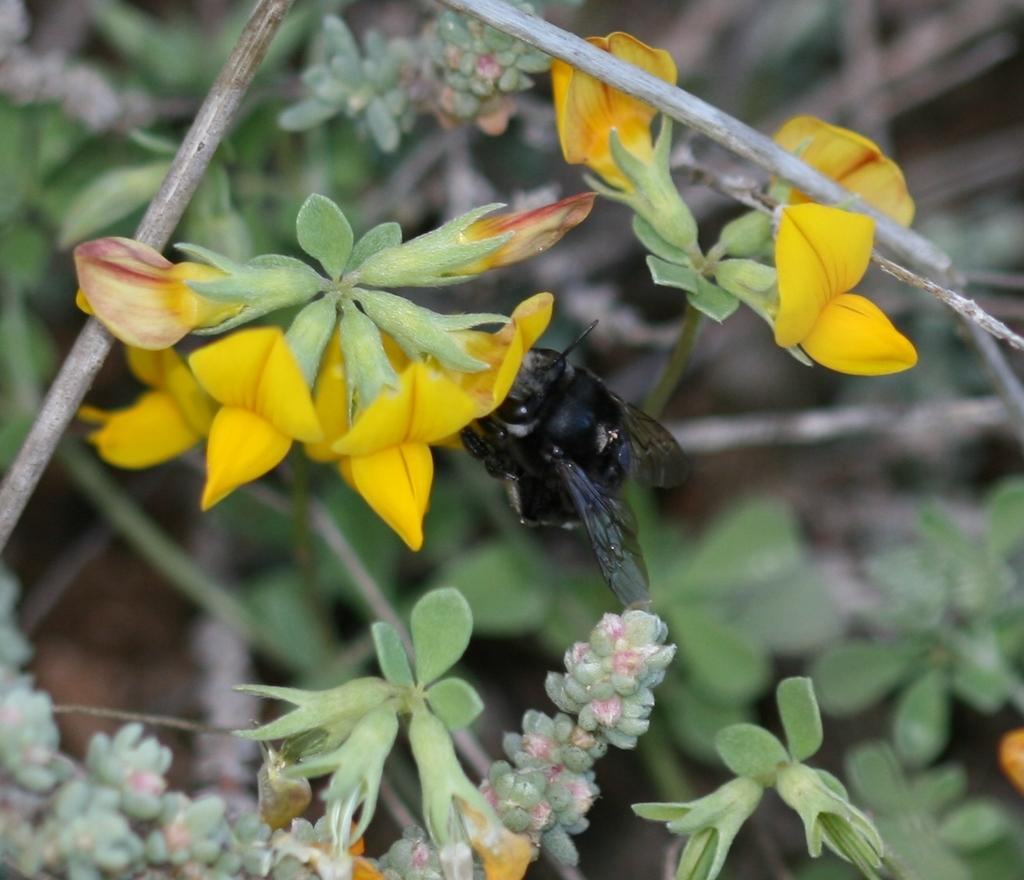What type of vegetation is present in the image? There are trees with flowers in the image. Can you describe any living organisms in the image? There is a black color insect in the image. What type of plastic material can be seen in the image? There is no plastic material present in the image. Can you describe any cats in the image? There are no cats present in the image. 